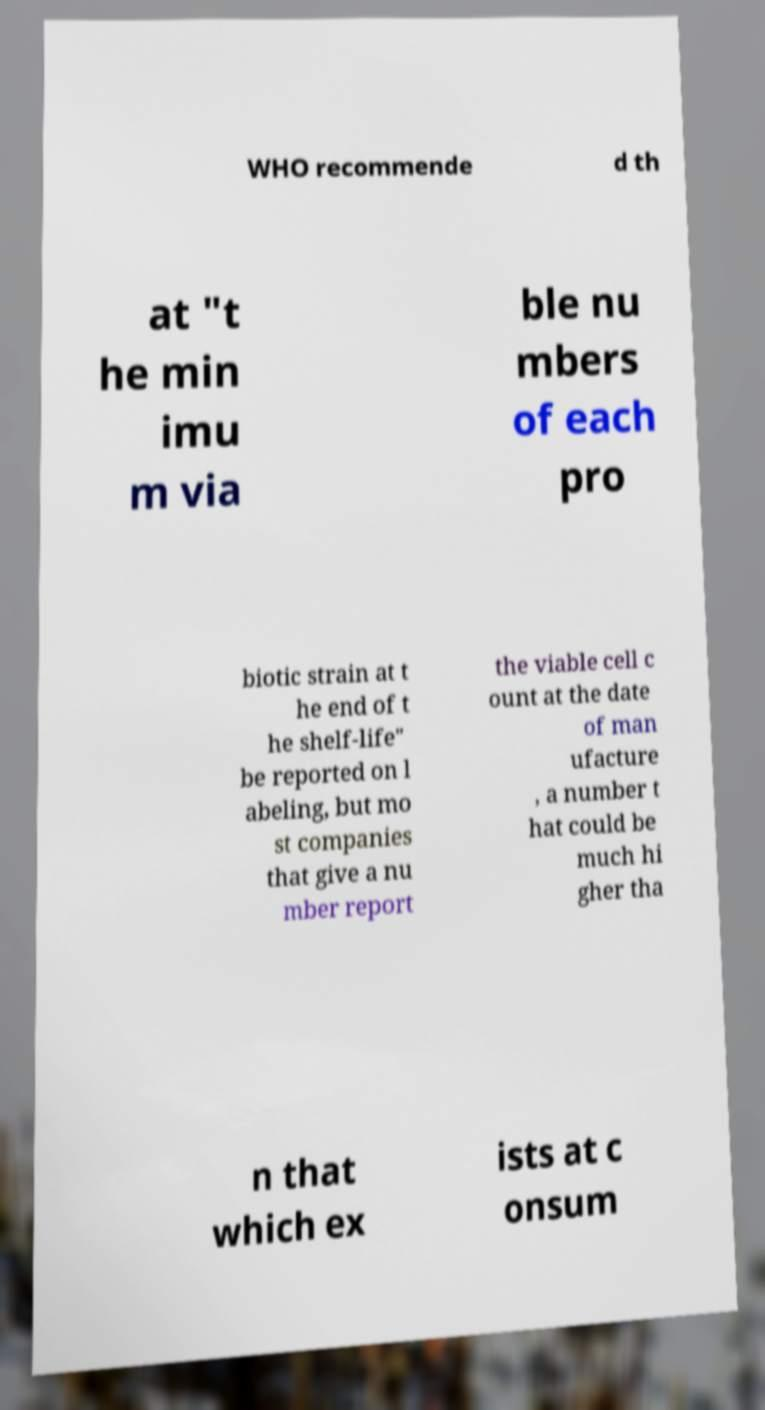Could you assist in decoding the text presented in this image and type it out clearly? WHO recommende d th at "t he min imu m via ble nu mbers of each pro biotic strain at t he end of t he shelf-life" be reported on l abeling, but mo st companies that give a nu mber report the viable cell c ount at the date of man ufacture , a number t hat could be much hi gher tha n that which ex ists at c onsum 